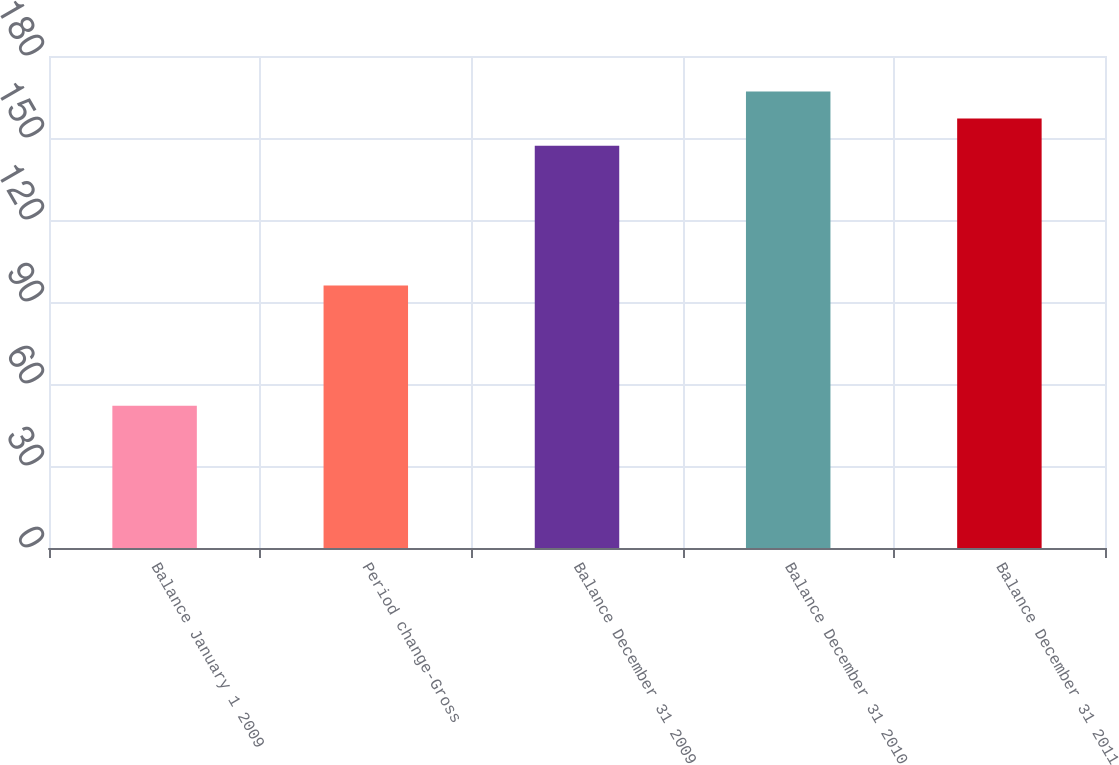Convert chart to OTSL. <chart><loc_0><loc_0><loc_500><loc_500><bar_chart><fcel>Balance January 1 2009<fcel>Period change-Gross<fcel>Balance December 31 2009<fcel>Balance December 31 2010<fcel>Balance December 31 2011<nl><fcel>52<fcel>96<fcel>147.2<fcel>167.02<fcel>157.11<nl></chart> 